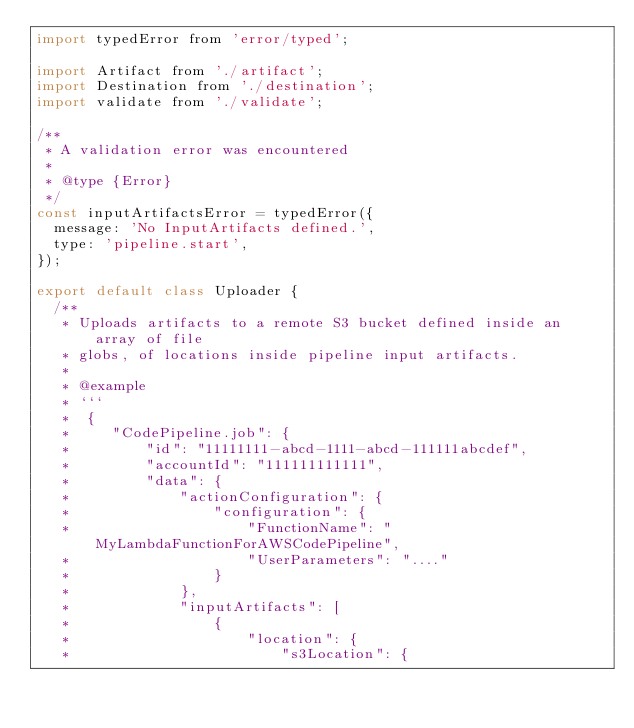Convert code to text. <code><loc_0><loc_0><loc_500><loc_500><_JavaScript_>import typedError from 'error/typed';

import Artifact from './artifact';
import Destination from './destination';
import validate from './validate';

/**
 * A validation error was encountered
 *
 * @type {Error}
 */
const inputArtifactsError = typedError({
  message: 'No InputArtifacts defined.',
  type: 'pipeline.start',
});

export default class Uploader {
  /**
   * Uploads artifacts to a remote S3 bucket defined inside an array of file
   * globs, of locations inside pipeline input artifacts.
   *
   * @example
   * ```
   *  {
   *     "CodePipeline.job": {
   *         "id": "11111111-abcd-1111-abcd-111111abcdef",
   *         "accountId": "111111111111",
   *         "data": {
   *             "actionConfiguration": {
   *                 "configuration": {
   *                     "FunctionName": "MyLambdaFunctionForAWSCodePipeline",
   *                     "UserParameters": "...."
   *                 }
   *             },
   *             "inputArtifacts": [
   *                 {
   *                     "location": {
   *                         "s3Location": {</code> 